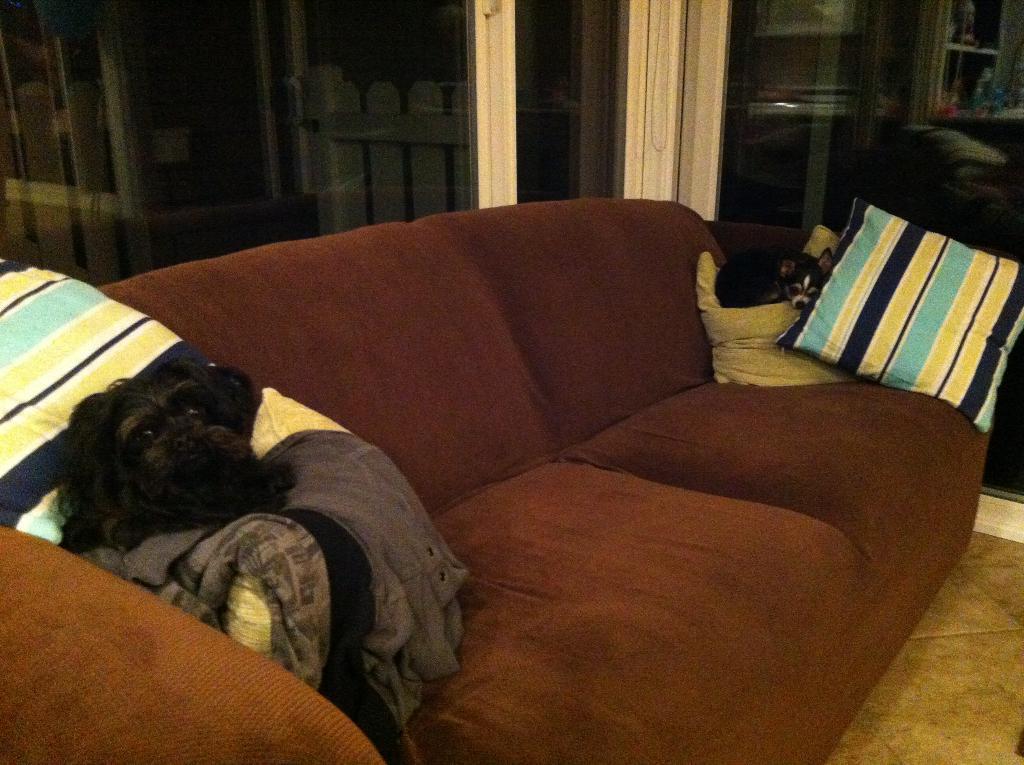Could you give a brief overview of what you see in this image? Here we can see a couch and we can see two dogs sitting on either end of the couch on the cushions present on the couch 